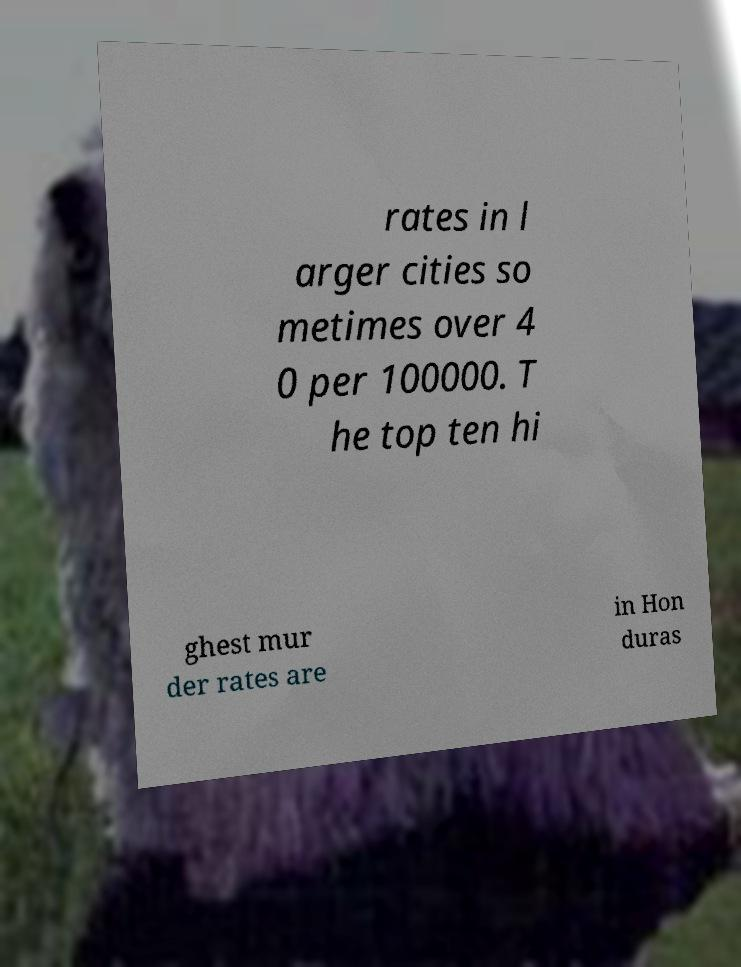Could you assist in decoding the text presented in this image and type it out clearly? rates in l arger cities so metimes over 4 0 per 100000. T he top ten hi ghest mur der rates are in Hon duras 